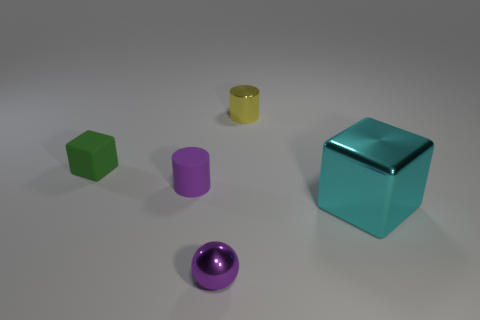Subtract all cyan cubes. How many cubes are left? 1 Add 1 tiny rubber cubes. How many objects exist? 6 Subtract 1 cubes. How many cubes are left? 1 Subtract all cubes. How many objects are left? 3 Subtract all large red rubber balls. Subtract all purple matte cylinders. How many objects are left? 4 Add 5 small shiny cylinders. How many small shiny cylinders are left? 6 Add 1 large yellow cylinders. How many large yellow cylinders exist? 1 Subtract 0 yellow spheres. How many objects are left? 5 Subtract all blue cubes. Subtract all gray balls. How many cubes are left? 2 Subtract all green cubes. How many yellow cylinders are left? 1 